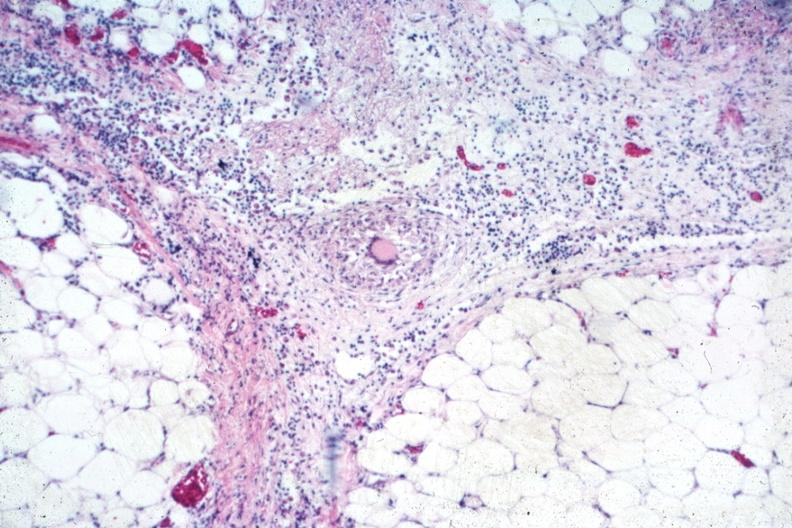does this image show outstanding example of granuloma with langhans giant cell?
Answer the question using a single word or phrase. Yes 